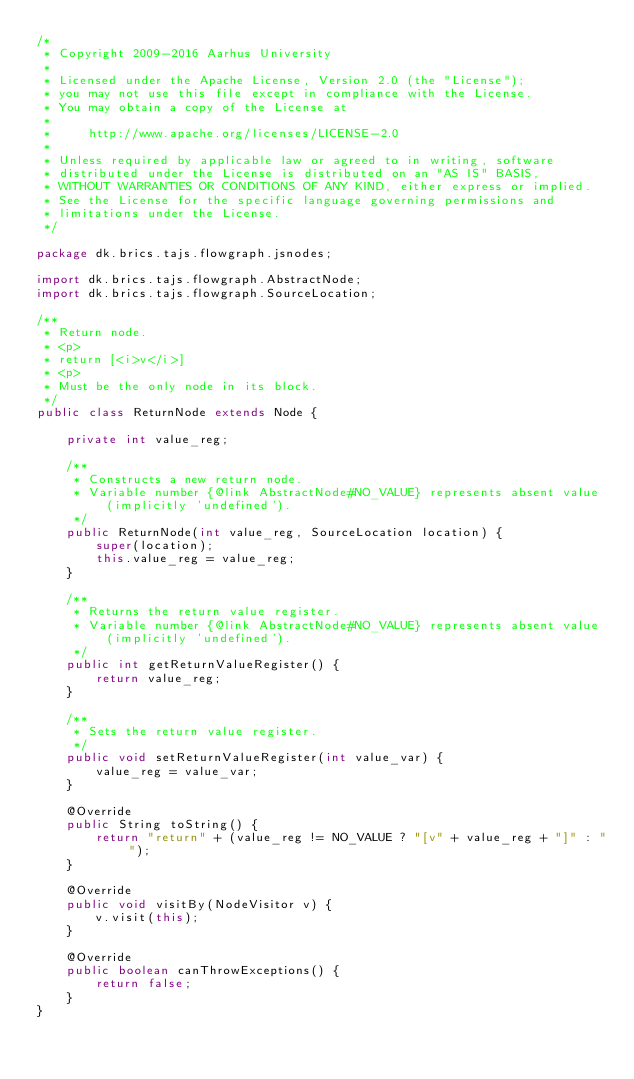<code> <loc_0><loc_0><loc_500><loc_500><_Java_>/*
 * Copyright 2009-2016 Aarhus University
 *
 * Licensed under the Apache License, Version 2.0 (the "License");
 * you may not use this file except in compliance with the License.
 * You may obtain a copy of the License at
 *
 *     http://www.apache.org/licenses/LICENSE-2.0
 *
 * Unless required by applicable law or agreed to in writing, software
 * distributed under the License is distributed on an "AS IS" BASIS,
 * WITHOUT WARRANTIES OR CONDITIONS OF ANY KIND, either express or implied.
 * See the License for the specific language governing permissions and
 * limitations under the License.
 */

package dk.brics.tajs.flowgraph.jsnodes;

import dk.brics.tajs.flowgraph.AbstractNode;
import dk.brics.tajs.flowgraph.SourceLocation;

/**
 * Return node.
 * <p>
 * return [<i>v</i>]
 * <p>
 * Must be the only node in its block.
 */
public class ReturnNode extends Node {

    private int value_reg;

    /**
     * Constructs a new return node.
     * Variable number {@link AbstractNode#NO_VALUE} represents absent value (implicitly 'undefined').
     */
    public ReturnNode(int value_reg, SourceLocation location) {
        super(location);
        this.value_reg = value_reg;
    }

    /**
     * Returns the return value register.
     * Variable number {@link AbstractNode#NO_VALUE} represents absent value (implicitly 'undefined').
     */
    public int getReturnValueRegister() {
        return value_reg;
    }

    /**
     * Sets the return value register.
     */
    public void setReturnValueRegister(int value_var) {
        value_reg = value_var;
    }

    @Override
    public String toString() {
        return "return" + (value_reg != NO_VALUE ? "[v" + value_reg + "]" : "");
    }

    @Override
    public void visitBy(NodeVisitor v) {
        v.visit(this);
    }

    @Override
    public boolean canThrowExceptions() {
        return false;
    }
}
</code> 